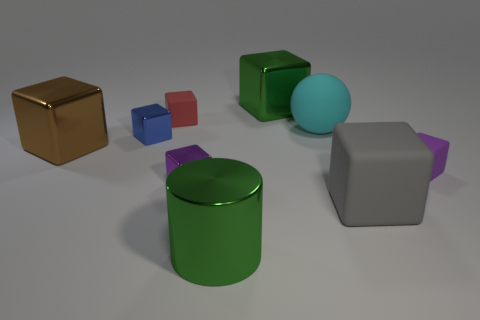Subtract all purple spheres. How many purple cubes are left? 2 Subtract all red blocks. How many blocks are left? 6 Subtract all green blocks. How many blocks are left? 6 Add 1 spheres. How many objects exist? 10 Subtract all cylinders. How many objects are left? 8 Subtract all cyan blocks. Subtract all yellow cylinders. How many blocks are left? 7 Subtract all brown metallic cubes. Subtract all big cyan objects. How many objects are left? 7 Add 5 cyan objects. How many cyan objects are left? 6 Add 4 large green cylinders. How many large green cylinders exist? 5 Subtract 0 cyan cylinders. How many objects are left? 9 